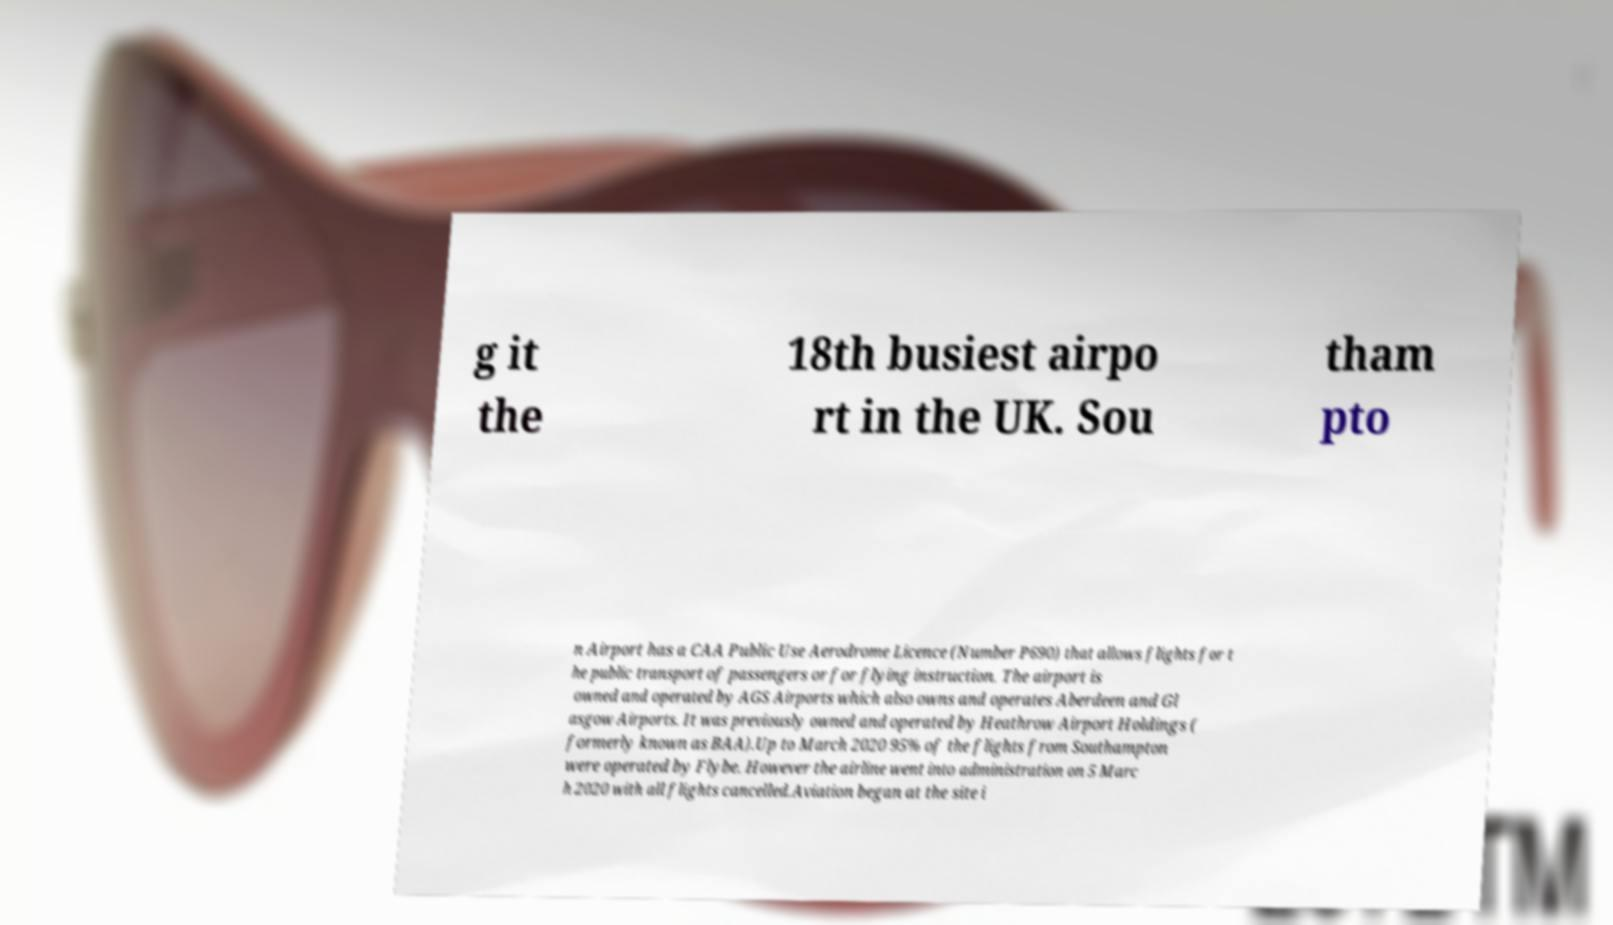There's text embedded in this image that I need extracted. Can you transcribe it verbatim? g it the 18th busiest airpo rt in the UK. Sou tham pto n Airport has a CAA Public Use Aerodrome Licence (Number P690) that allows flights for t he public transport of passengers or for flying instruction. The airport is owned and operated by AGS Airports which also owns and operates Aberdeen and Gl asgow Airports. It was previously owned and operated by Heathrow Airport Holdings ( formerly known as BAA).Up to March 2020 95% of the flights from Southampton were operated by Flybe. However the airline went into administration on 5 Marc h 2020 with all flights cancelled.Aviation began at the site i 